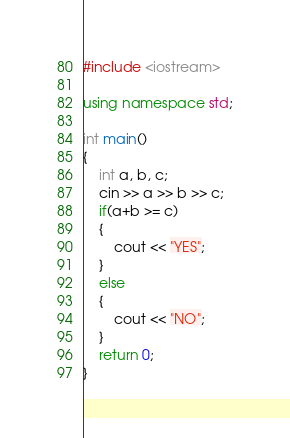Convert code to text. <code><loc_0><loc_0><loc_500><loc_500><_C++_>#include <iostream>

using namespace std;

int main()
{
    int a, b, c;
    cin >> a >> b >> c;
    if(a+b >= c)
    {
        cout << "YES";
    }
    else
    {
        cout << "NO";
    }
    return 0;
}
</code> 